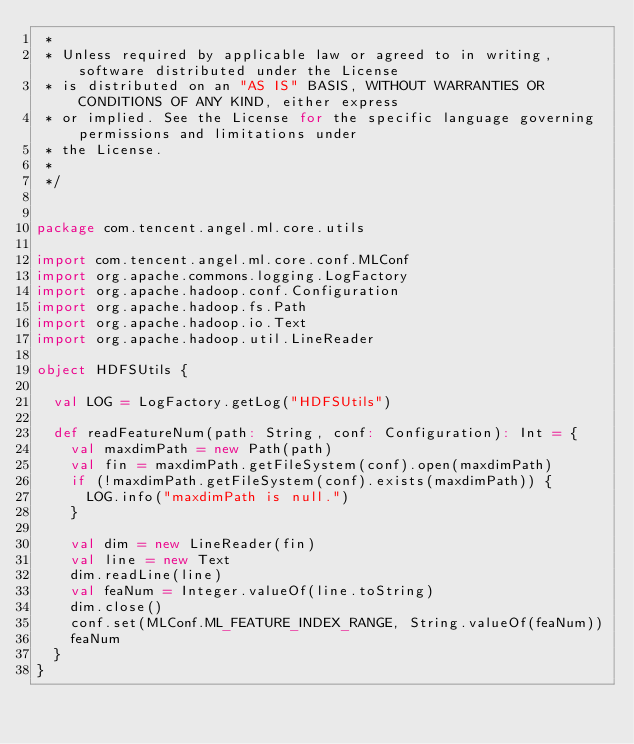<code> <loc_0><loc_0><loc_500><loc_500><_Scala_> *
 * Unless required by applicable law or agreed to in writing, software distributed under the License
 * is distributed on an "AS IS" BASIS, WITHOUT WARRANTIES OR CONDITIONS OF ANY KIND, either express
 * or implied. See the License for the specific language governing permissions and limitations under
 * the License.
 *
 */


package com.tencent.angel.ml.core.utils

import com.tencent.angel.ml.core.conf.MLConf
import org.apache.commons.logging.LogFactory
import org.apache.hadoop.conf.Configuration
import org.apache.hadoop.fs.Path
import org.apache.hadoop.io.Text
import org.apache.hadoop.util.LineReader

object HDFSUtils {

  val LOG = LogFactory.getLog("HDFSUtils")

  def readFeatureNum(path: String, conf: Configuration): Int = {
    val maxdimPath = new Path(path)
    val fin = maxdimPath.getFileSystem(conf).open(maxdimPath)
    if (!maxdimPath.getFileSystem(conf).exists(maxdimPath)) {
      LOG.info("maxdimPath is null.")
    }

    val dim = new LineReader(fin)
    val line = new Text
    dim.readLine(line)
    val feaNum = Integer.valueOf(line.toString)
    dim.close()
    conf.set(MLConf.ML_FEATURE_INDEX_RANGE, String.valueOf(feaNum))
    feaNum
  }
}</code> 